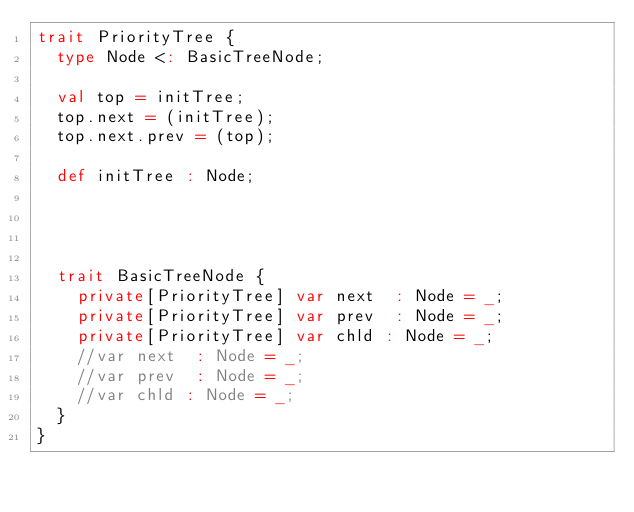<code> <loc_0><loc_0><loc_500><loc_500><_Scala_>trait PriorityTree {
  type Node <: BasicTreeNode;

  val top = initTree;
  top.next = (initTree);
  top.next.prev = (top);

  def initTree : Node;




  trait BasicTreeNode {
    private[PriorityTree] var next  : Node = _;
    private[PriorityTree] var prev  : Node = _;
    private[PriorityTree] var chld : Node = _;
    //var next  : Node = _;
    //var prev  : Node = _;
    //var chld : Node = _;
  }
}
</code> 